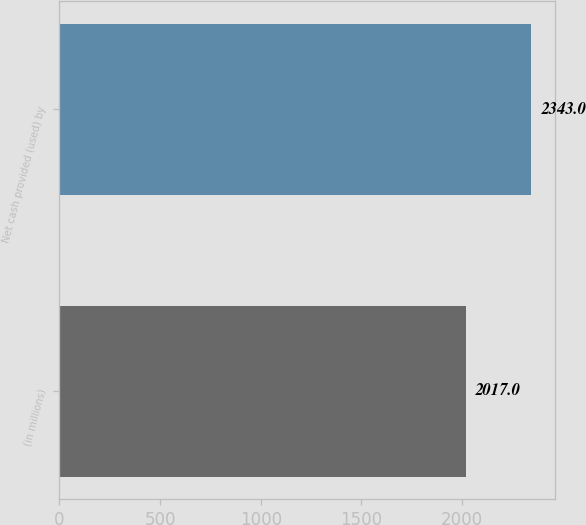Convert chart. <chart><loc_0><loc_0><loc_500><loc_500><bar_chart><fcel>(in millions)<fcel>Net cash provided (used) by<nl><fcel>2017<fcel>2343<nl></chart> 